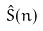Convert formula to latex. <formula><loc_0><loc_0><loc_500><loc_500>\hat { S } ( n )</formula> 